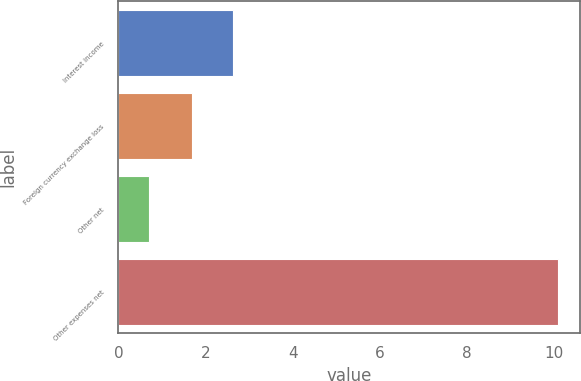<chart> <loc_0><loc_0><loc_500><loc_500><bar_chart><fcel>Interest income<fcel>Foreign currency exchange loss<fcel>Other net<fcel>Other expenses net<nl><fcel>2.64<fcel>1.7<fcel>0.7<fcel>10.1<nl></chart> 